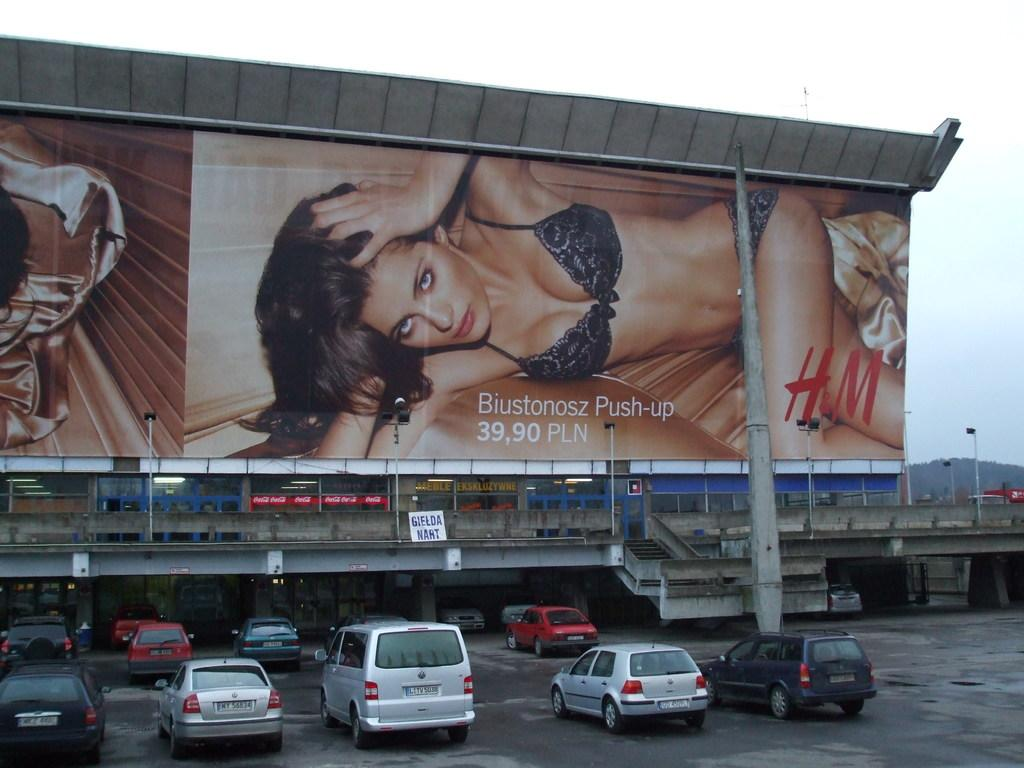<image>
Relay a brief, clear account of the picture shown. A billboard with a woman promoting a bra by Biustonosz. 